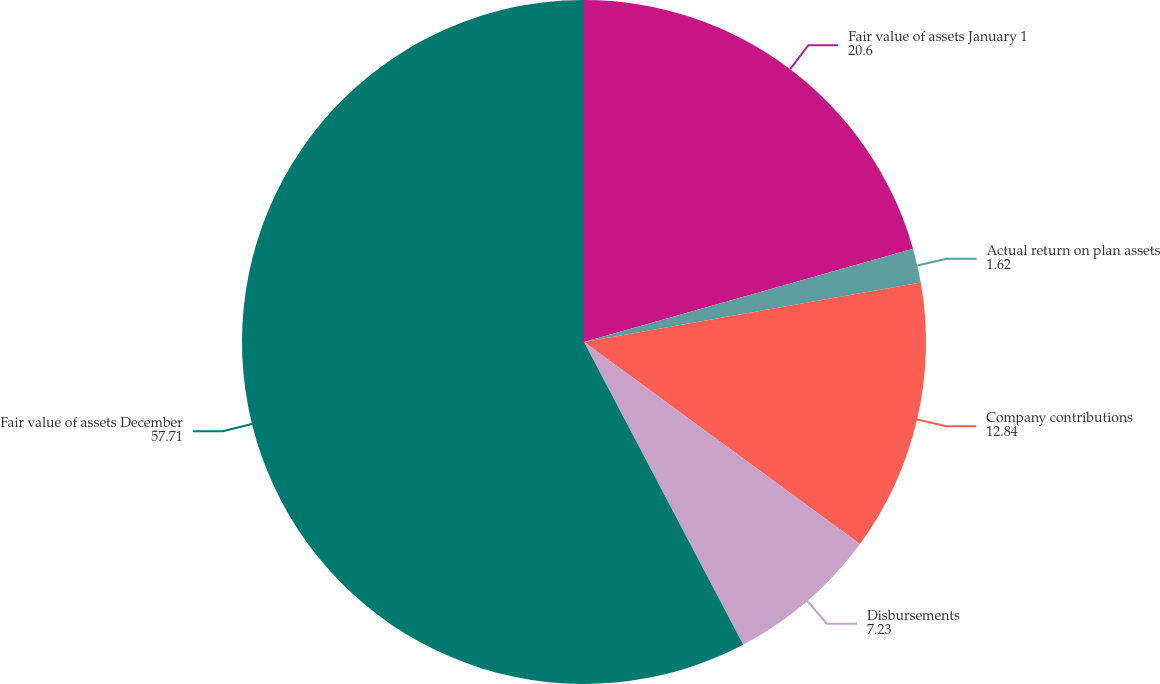<chart> <loc_0><loc_0><loc_500><loc_500><pie_chart><fcel>Fair value of assets January 1<fcel>Actual return on plan assets<fcel>Company contributions<fcel>Disbursements<fcel>Fair value of assets December<nl><fcel>20.6%<fcel>1.62%<fcel>12.84%<fcel>7.23%<fcel>57.71%<nl></chart> 